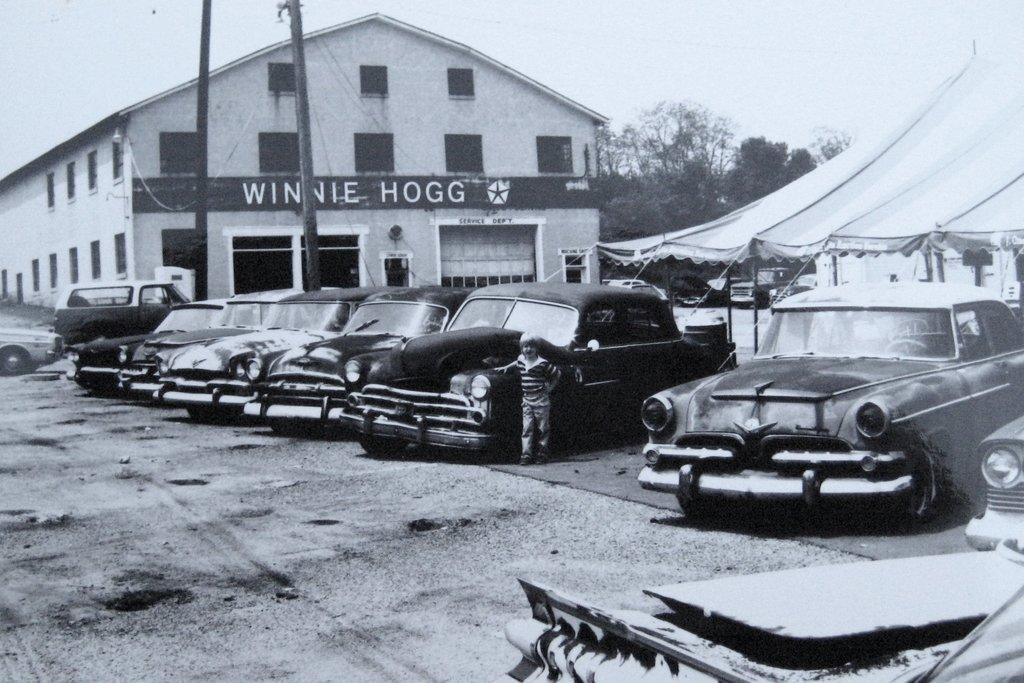Can you describe this image briefly? This is a black and white image and here we can see vehicles on the road and in the background, we can see a building, a tent, a person, trees and there is a pole along with wires. At the top, there is sky. 